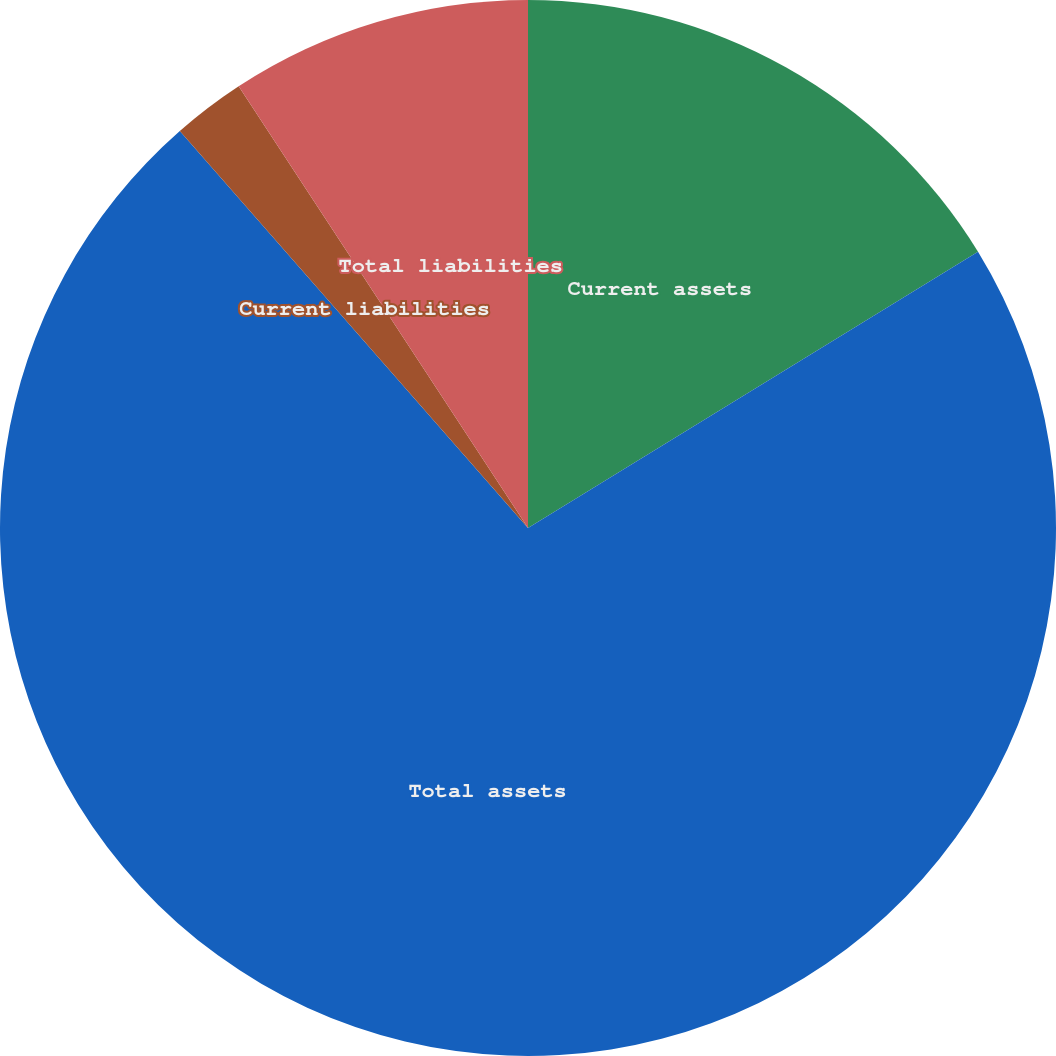Convert chart to OTSL. <chart><loc_0><loc_0><loc_500><loc_500><pie_chart><fcel>Current assets<fcel>Total assets<fcel>Current liabilities<fcel>Total liabilities<nl><fcel>16.24%<fcel>72.3%<fcel>2.23%<fcel>9.23%<nl></chart> 